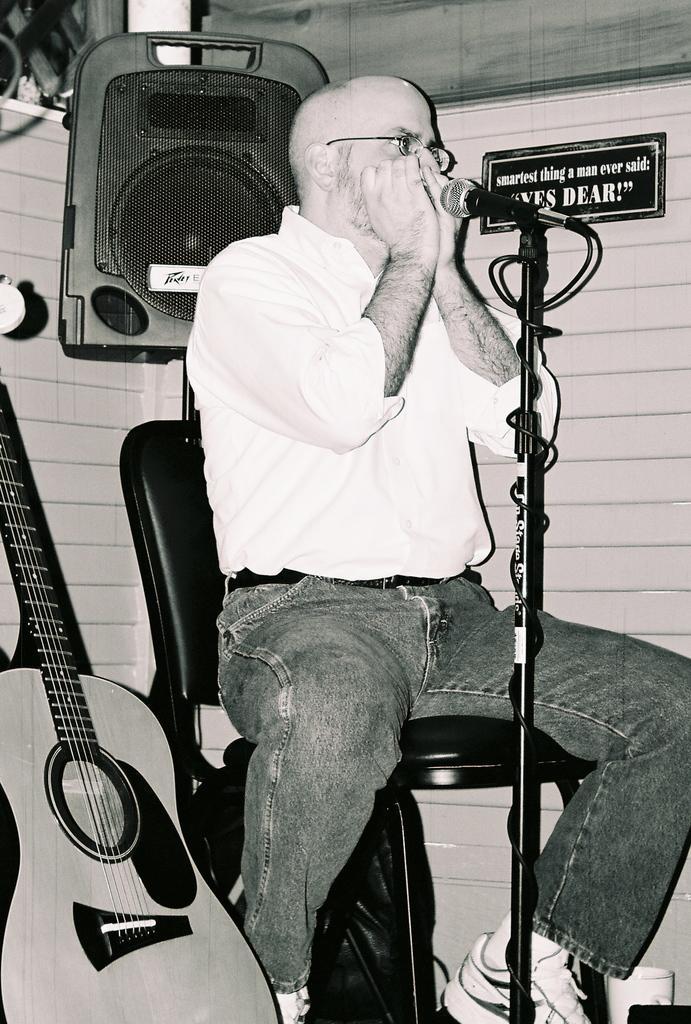How would you summarize this image in a sentence or two? This picture shows a man sitting in the chair, speaking in front of a mic and a stand. There is a speaker behind him. He is wearing spectacles. In the background there is a wall. Beside him, there is a guitar. 